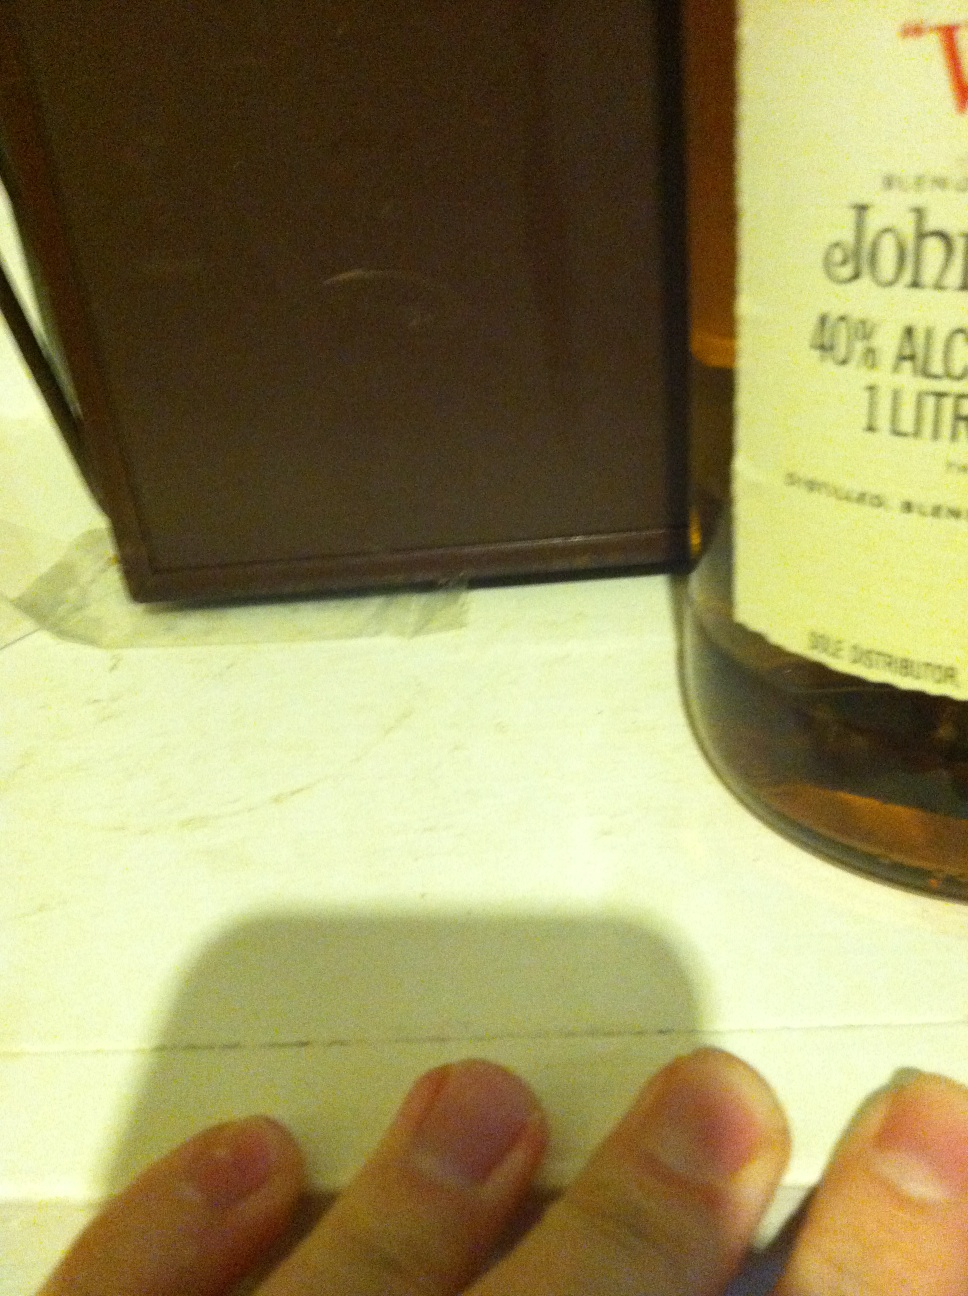Imagine the story behind this bottle. This bottle of whisky might tell a story of tradition and craftsmanship. It could come from a small distillery run by a family who has passed down the art of whisky-making through generations. Every bottle is crafted with care, using a blend of premium ingredients, matured to perfection. Who is the target audience for this whisky? This whisky seems to be targeted at connoisseurs and enthusiasts who appreciate quality and tradition. It's likely marketed towards individuals who enjoy savoring their drinks, possibly in a relaxed or celebratory setting. Its classic design hints at a premium product aimed at those who value authenticity. 